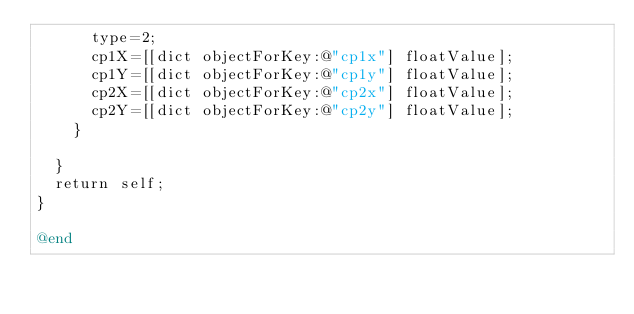<code> <loc_0><loc_0><loc_500><loc_500><_ObjectiveC_>			type=2;
			cp1X=[[dict objectForKey:@"cp1x"] floatValue];
			cp1Y=[[dict objectForKey:@"cp1y"] floatValue];
			cp2X=[[dict objectForKey:@"cp2x"] floatValue];
			cp2Y=[[dict objectForKey:@"cp2y"] floatValue];
		}
		
	}
	return self;
}

@end
</code> 